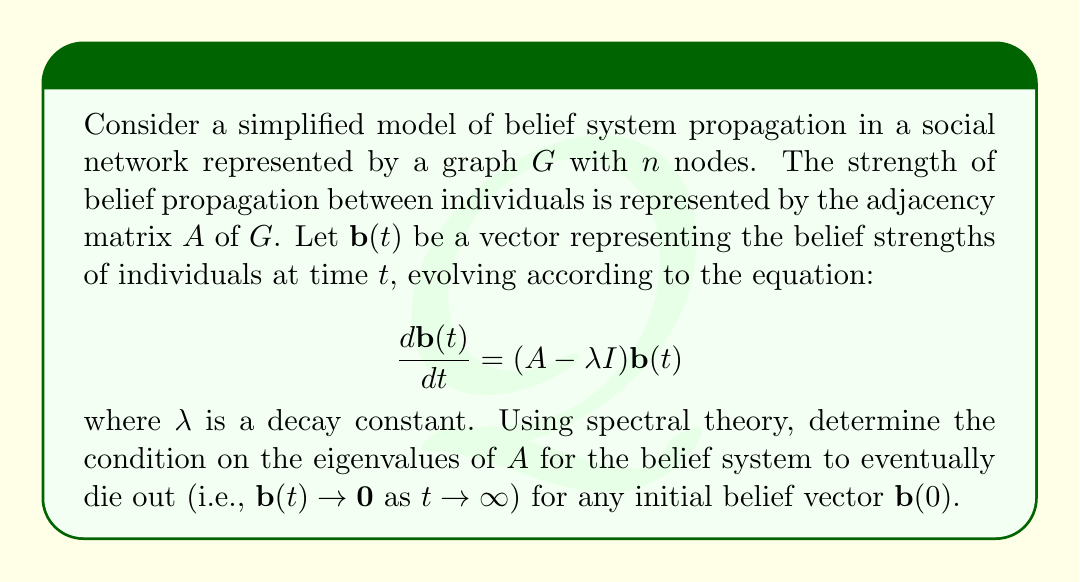Could you help me with this problem? To solve this problem, we'll use spectral theory to analyze the behavior of the system:

1) The general solution to the differential equation is of the form:
   $$\mathbf{b}(t) = e^{(A-\lambda I)t}\mathbf{b}(0)$$

2) Let $\mu_i$ be the eigenvalues of $A$, and $\mathbf{v}_i$ the corresponding eigenvectors. We can decompose $\mathbf{b}(0)$ in terms of these eigenvectors:
   $$\mathbf{b}(0) = \sum_{i=1}^n c_i\mathbf{v}_i$$

3) The solution can then be written as:
   $$\mathbf{b}(t) = \sum_{i=1}^n c_ie^{(\mu_i-\lambda)t}\mathbf{v}_i$$

4) For the belief system to die out, we need all components of $\mathbf{b}(t)$ to approach 0 as $t \to \infty$. This occurs when:
   $$e^{(\mu_i-\lambda)t} \to 0 \text{ as } t \to \infty, \text{ for all } i$$

5) This condition is satisfied when:
   $$\mu_i - \lambda < 0 \text{ for all } i$$

6) Rearranging this inequality:
   $$\mu_i < \lambda \text{ for all } i$$

7) Since this must hold for all eigenvalues, we can express it in terms of the spectral radius $\rho(A)$, which is the largest absolute value of the eigenvalues:
   $$\rho(A) < \lambda$$

This condition ensures that the belief system will eventually die out regardless of the initial belief vector.
Answer: The condition for the belief system to eventually die out for any initial belief vector is:

$$\rho(A) < \lambda$$

where $\rho(A)$ is the spectral radius of the adjacency matrix $A$, and $\lambda$ is the decay constant. 